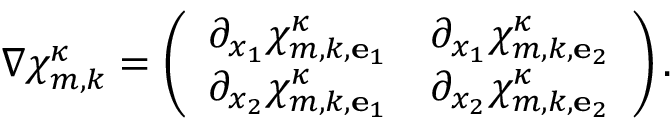Convert formula to latex. <formula><loc_0><loc_0><loc_500><loc_500>\nabla { \chi } _ { m , k } ^ { \kappa } = \left ( \begin{array} { l l } { \partial _ { x _ { 1 } } \chi _ { m , k , { e } _ { 1 } } ^ { \kappa } } & { \partial _ { x _ { 1 } } \chi _ { m , k , { e } _ { 2 } } ^ { \kappa } } \\ { \partial _ { x _ { 2 } } \chi _ { m , k , { e } _ { 1 } } ^ { \kappa } } & { \partial _ { x _ { 2 } } \chi _ { m , k , { e } _ { 2 } } ^ { \kappa } } \end{array} \right ) .</formula> 